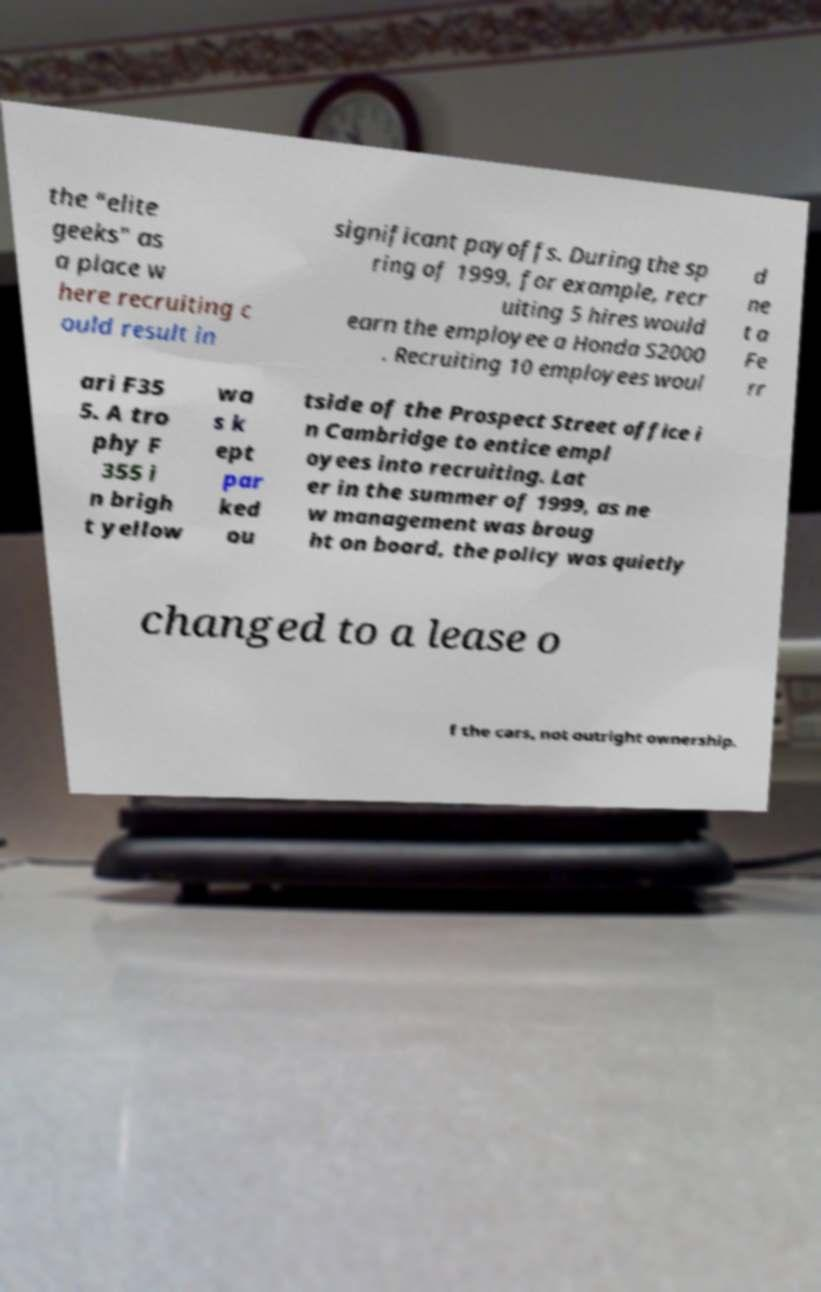I need the written content from this picture converted into text. Can you do that? the "elite geeks" as a place w here recruiting c ould result in significant payoffs. During the sp ring of 1999, for example, recr uiting 5 hires would earn the employee a Honda S2000 . Recruiting 10 employees woul d ne t a Fe rr ari F35 5. A tro phy F 355 i n brigh t yellow wa s k ept par ked ou tside of the Prospect Street office i n Cambridge to entice empl oyees into recruiting. Lat er in the summer of 1999, as ne w management was broug ht on board, the policy was quietly changed to a lease o f the cars, not outright ownership. 